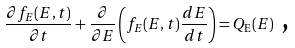<formula> <loc_0><loc_0><loc_500><loc_500>\frac { \partial f _ { E } ( E , t ) } { \partial t } + \frac { \partial } { \partial E } \left ( f _ { E } ( E , t ) \frac { d E } { d t } \right ) = Q _ { \text {E} } ( E ) \text { ,}</formula> 